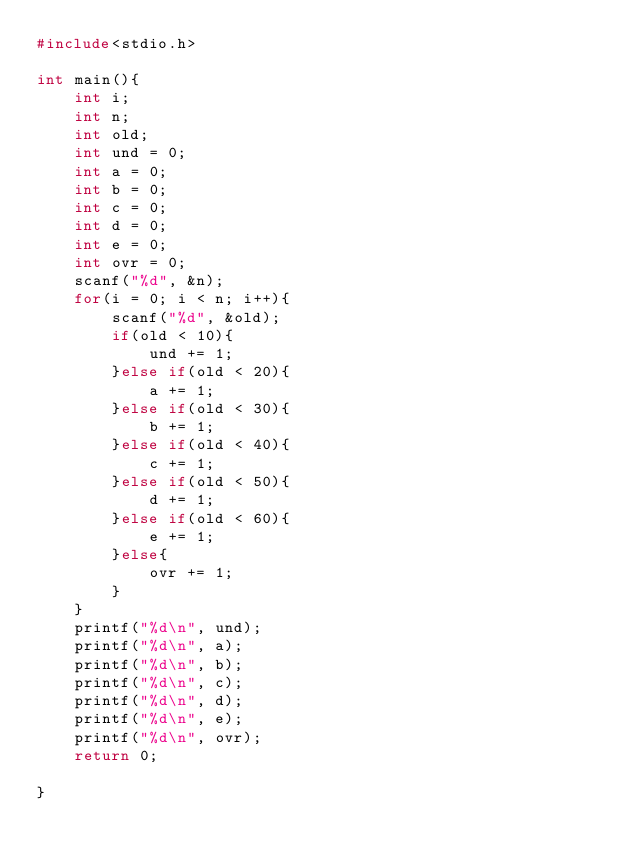<code> <loc_0><loc_0><loc_500><loc_500><_C_>#include<stdio.h>

int main(){
	int i;
	int n;
	int old;
	int und = 0;
	int a = 0;
	int b = 0;
	int c = 0;
	int d = 0;
	int e = 0;
	int ovr = 0;
	scanf("%d", &n);
	for(i = 0; i < n; i++){
		scanf("%d", &old);
		if(old < 10){
			und += 1;
		}else if(old < 20){
			a += 1;
		}else if(old < 30){
			b += 1;
		}else if(old < 40){
			c += 1;
		}else if(old < 50){
			d += 1;
		}else if(old < 60){
			e += 1;
		}else{
			ovr += 1;
		}
	}
	printf("%d\n", und);
	printf("%d\n", a);
	printf("%d\n", b);
	printf("%d\n", c);
	printf("%d\n", d);
	printf("%d\n", e);
	printf("%d\n", ovr);
	return 0;

}</code> 